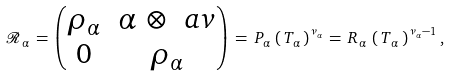<formula> <loc_0><loc_0><loc_500><loc_500>\mathcal { R } _ { \, \alpha } \, = \, \begin{pmatrix} \rho _ { \alpha } & \alpha \, \otimes \, \ a v \\ 0 & \rho _ { \alpha } \end{pmatrix} \, = \, P _ { \alpha } \, \left ( \, T _ { \alpha } \, \right ) ^ { \nu _ { \alpha } } \, = \, R _ { \, \alpha } \, \left ( \, T _ { \, \alpha } \, \right ) ^ { \, \nu _ { \alpha } - 1 } ,</formula> 